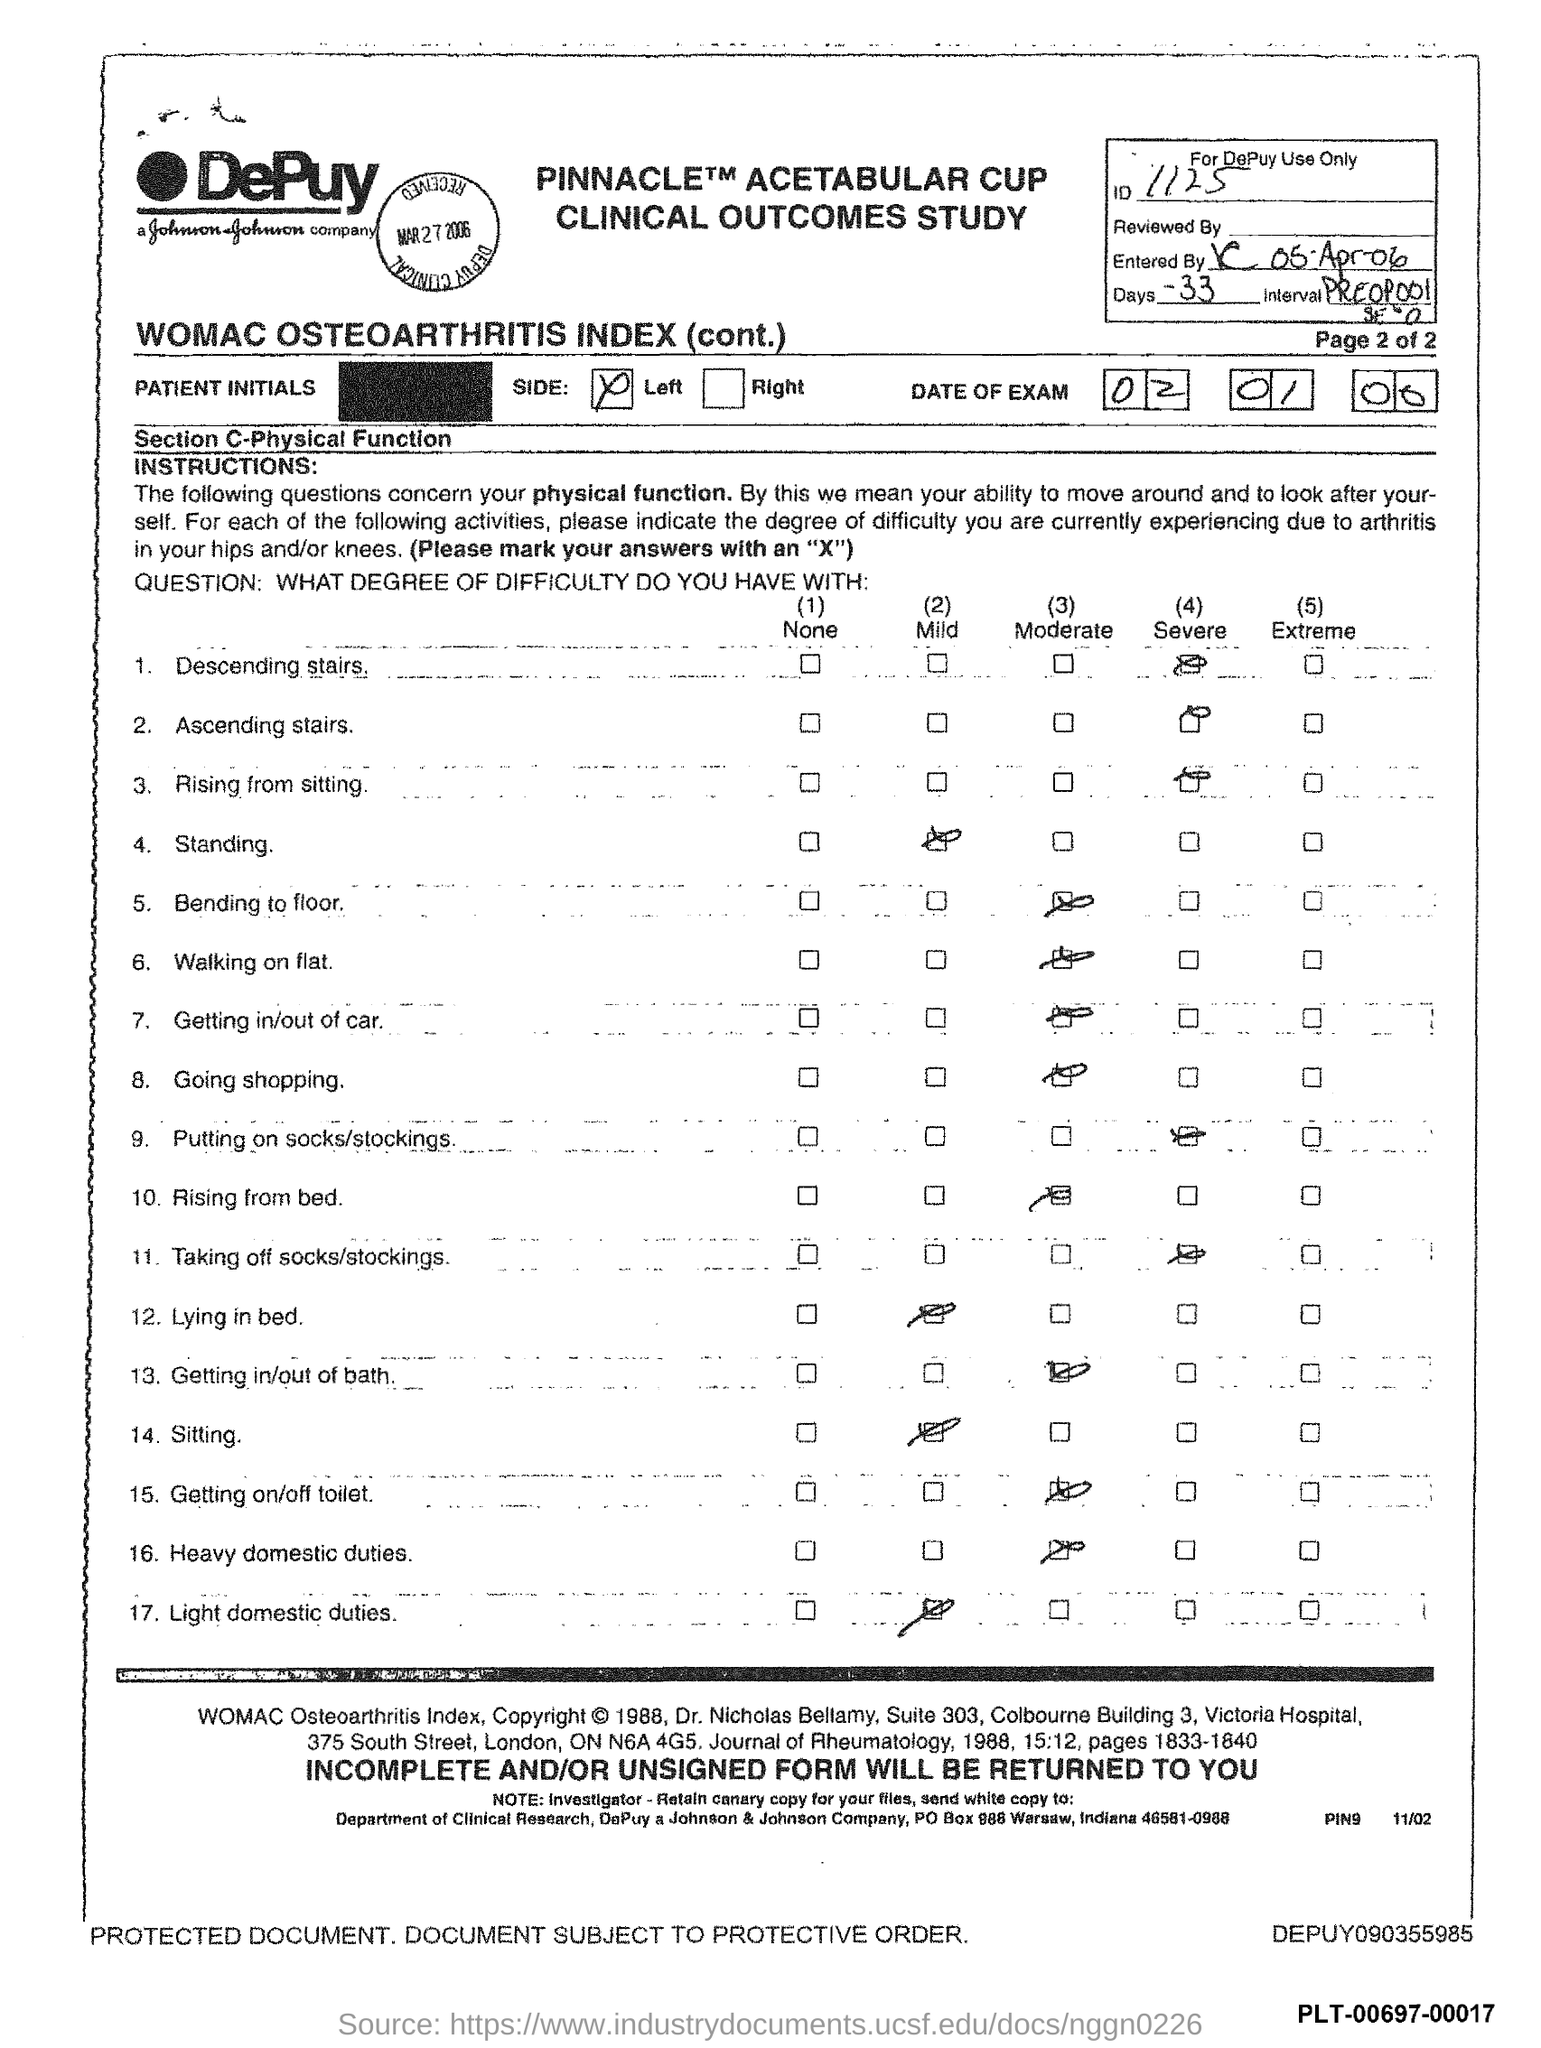What is the ID Number?
Your response must be concise. 1125. What is the number of days?
Give a very brief answer. -33. 